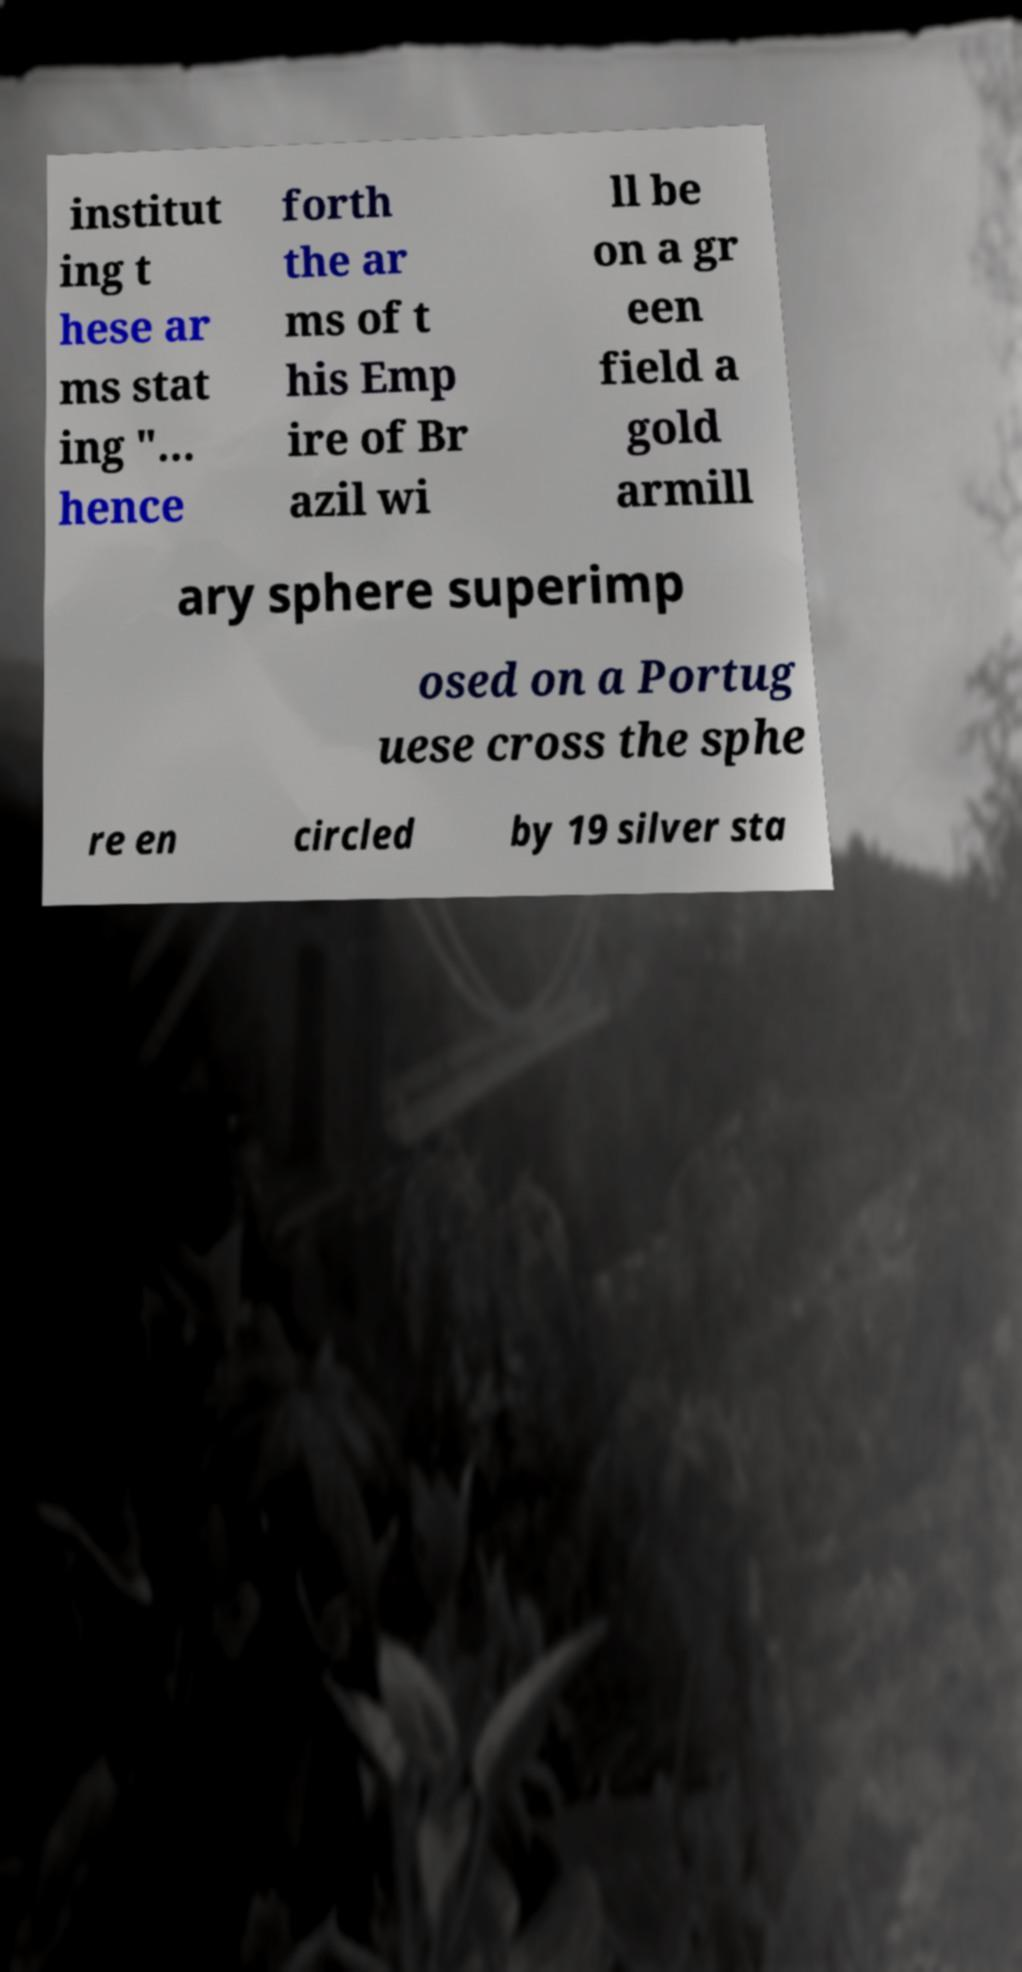For documentation purposes, I need the text within this image transcribed. Could you provide that? institut ing t hese ar ms stat ing "... hence forth the ar ms of t his Emp ire of Br azil wi ll be on a gr een field a gold armill ary sphere superimp osed on a Portug uese cross the sphe re en circled by 19 silver sta 